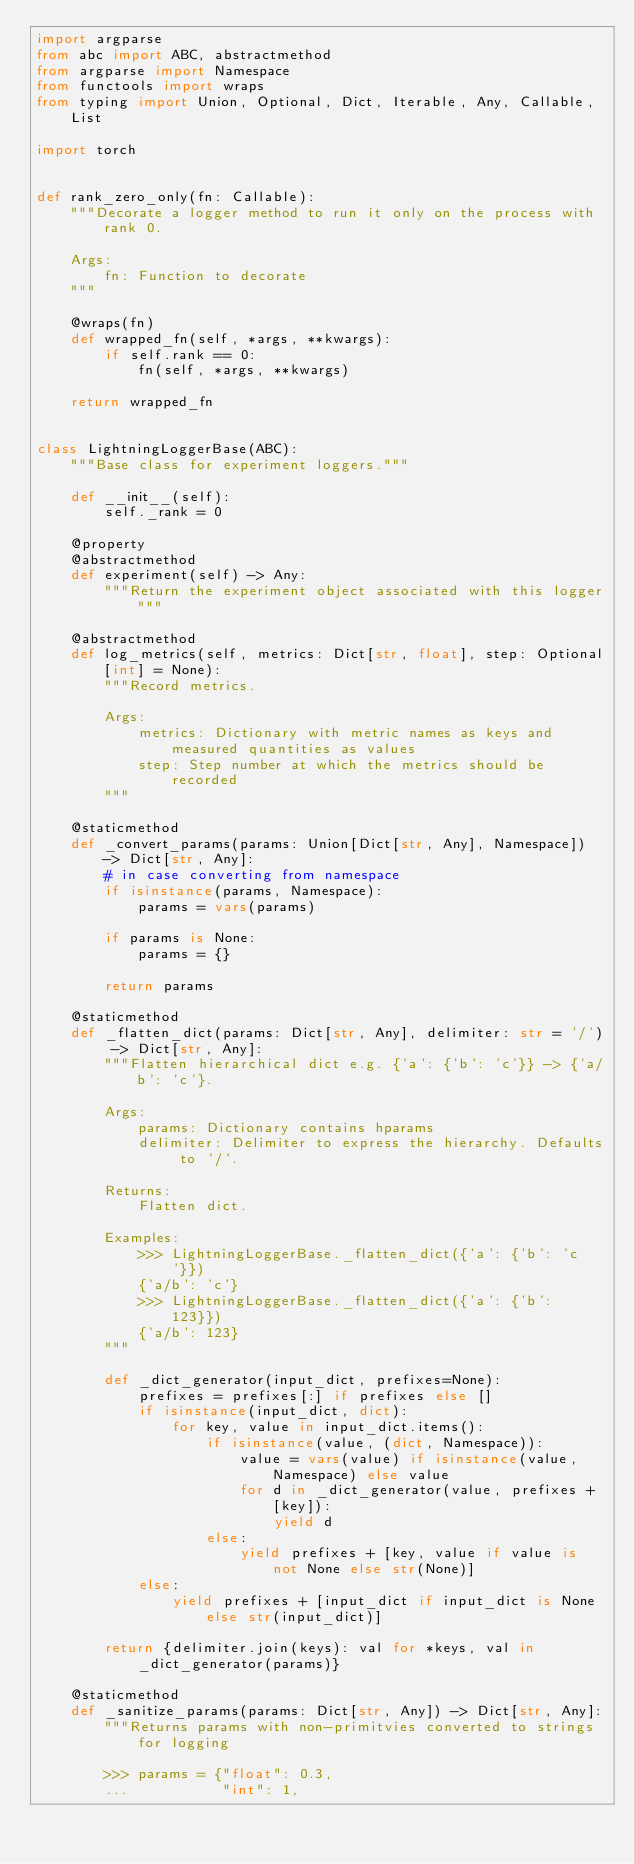<code> <loc_0><loc_0><loc_500><loc_500><_Python_>import argparse
from abc import ABC, abstractmethod
from argparse import Namespace
from functools import wraps
from typing import Union, Optional, Dict, Iterable, Any, Callable, List

import torch


def rank_zero_only(fn: Callable):
    """Decorate a logger method to run it only on the process with rank 0.

    Args:
        fn: Function to decorate
    """

    @wraps(fn)
    def wrapped_fn(self, *args, **kwargs):
        if self.rank == 0:
            fn(self, *args, **kwargs)

    return wrapped_fn


class LightningLoggerBase(ABC):
    """Base class for experiment loggers."""

    def __init__(self):
        self._rank = 0

    @property
    @abstractmethod
    def experiment(self) -> Any:
        """Return the experiment object associated with this logger"""

    @abstractmethod
    def log_metrics(self, metrics: Dict[str, float], step: Optional[int] = None):
        """Record metrics.

        Args:
            metrics: Dictionary with metric names as keys and measured quantities as values
            step: Step number at which the metrics should be recorded
        """

    @staticmethod
    def _convert_params(params: Union[Dict[str, Any], Namespace]) -> Dict[str, Any]:
        # in case converting from namespace
        if isinstance(params, Namespace):
            params = vars(params)

        if params is None:
            params = {}

        return params

    @staticmethod
    def _flatten_dict(params: Dict[str, Any], delimiter: str = '/') -> Dict[str, Any]:
        """Flatten hierarchical dict e.g. {'a': {'b': 'c'}} -> {'a/b': 'c'}.

        Args:
            params: Dictionary contains hparams
            delimiter: Delimiter to express the hierarchy. Defaults to '/'.

        Returns:
            Flatten dict.

        Examples:
            >>> LightningLoggerBase._flatten_dict({'a': {'b': 'c'}})
            {'a/b': 'c'}
            >>> LightningLoggerBase._flatten_dict({'a': {'b': 123}})
            {'a/b': 123}
        """

        def _dict_generator(input_dict, prefixes=None):
            prefixes = prefixes[:] if prefixes else []
            if isinstance(input_dict, dict):
                for key, value in input_dict.items():
                    if isinstance(value, (dict, Namespace)):
                        value = vars(value) if isinstance(value, Namespace) else value
                        for d in _dict_generator(value, prefixes + [key]):
                            yield d
                    else:
                        yield prefixes + [key, value if value is not None else str(None)]
            else:
                yield prefixes + [input_dict if input_dict is None else str(input_dict)]

        return {delimiter.join(keys): val for *keys, val in _dict_generator(params)}

    @staticmethod
    def _sanitize_params(params: Dict[str, Any]) -> Dict[str, Any]:
        """Returns params with non-primitvies converted to strings for logging

        >>> params = {"float": 0.3,
        ...           "int": 1,</code> 